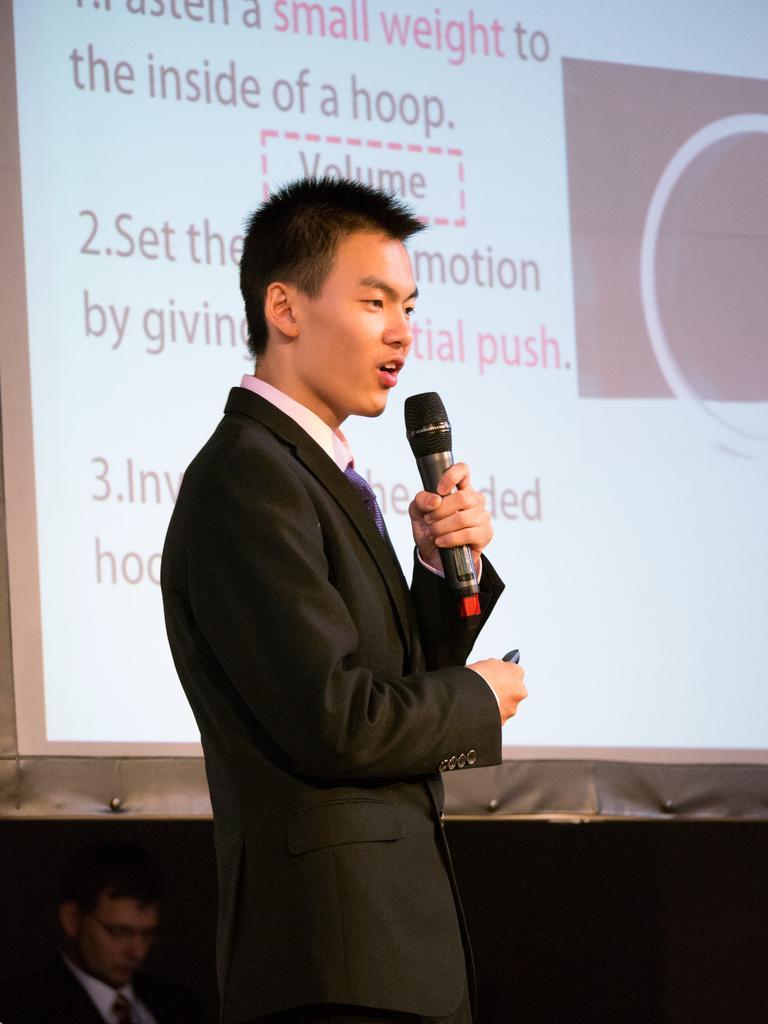Could you give a brief overview of what you see in this image? In this picture there is a man standing, speaking and there is a microphone in his left hand and background that is a screen 